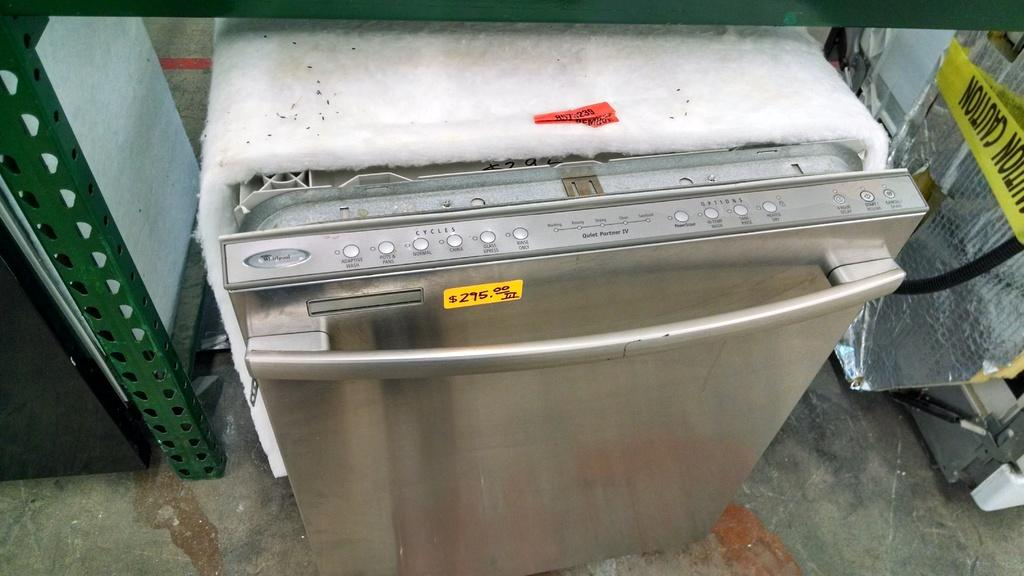<image>
Provide a brief description of the given image. The price of this dishwasher is 295 dollars. 